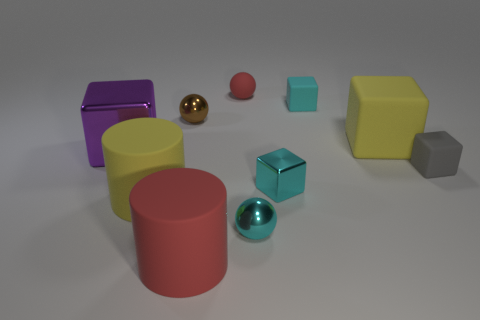Do the tiny gray matte object and the big metallic object have the same shape?
Keep it short and to the point. Yes. How many other objects are the same shape as the purple metal object?
Ensure brevity in your answer.  4. The cylinder that is to the left of the red rubber cylinder is what color?
Your answer should be compact. Yellow. Does the cyan shiny block have the same size as the yellow rubber cube?
Ensure brevity in your answer.  No. What material is the cube that is behind the yellow object behind the gray matte thing?
Keep it short and to the point. Rubber. What number of other large things have the same color as the large metal thing?
Your answer should be very brief. 0. Is the number of cyan rubber blocks in front of the big shiny block less than the number of blocks?
Your answer should be very brief. Yes. What is the color of the big rubber object that is behind the small cyan cube that is in front of the yellow block?
Offer a terse response. Yellow. There is a cyan thing behind the small cyan block in front of the big yellow object behind the small gray object; how big is it?
Keep it short and to the point. Small. Is the number of small brown spheres in front of the large red cylinder less than the number of large rubber things that are right of the red ball?
Your answer should be very brief. Yes. 